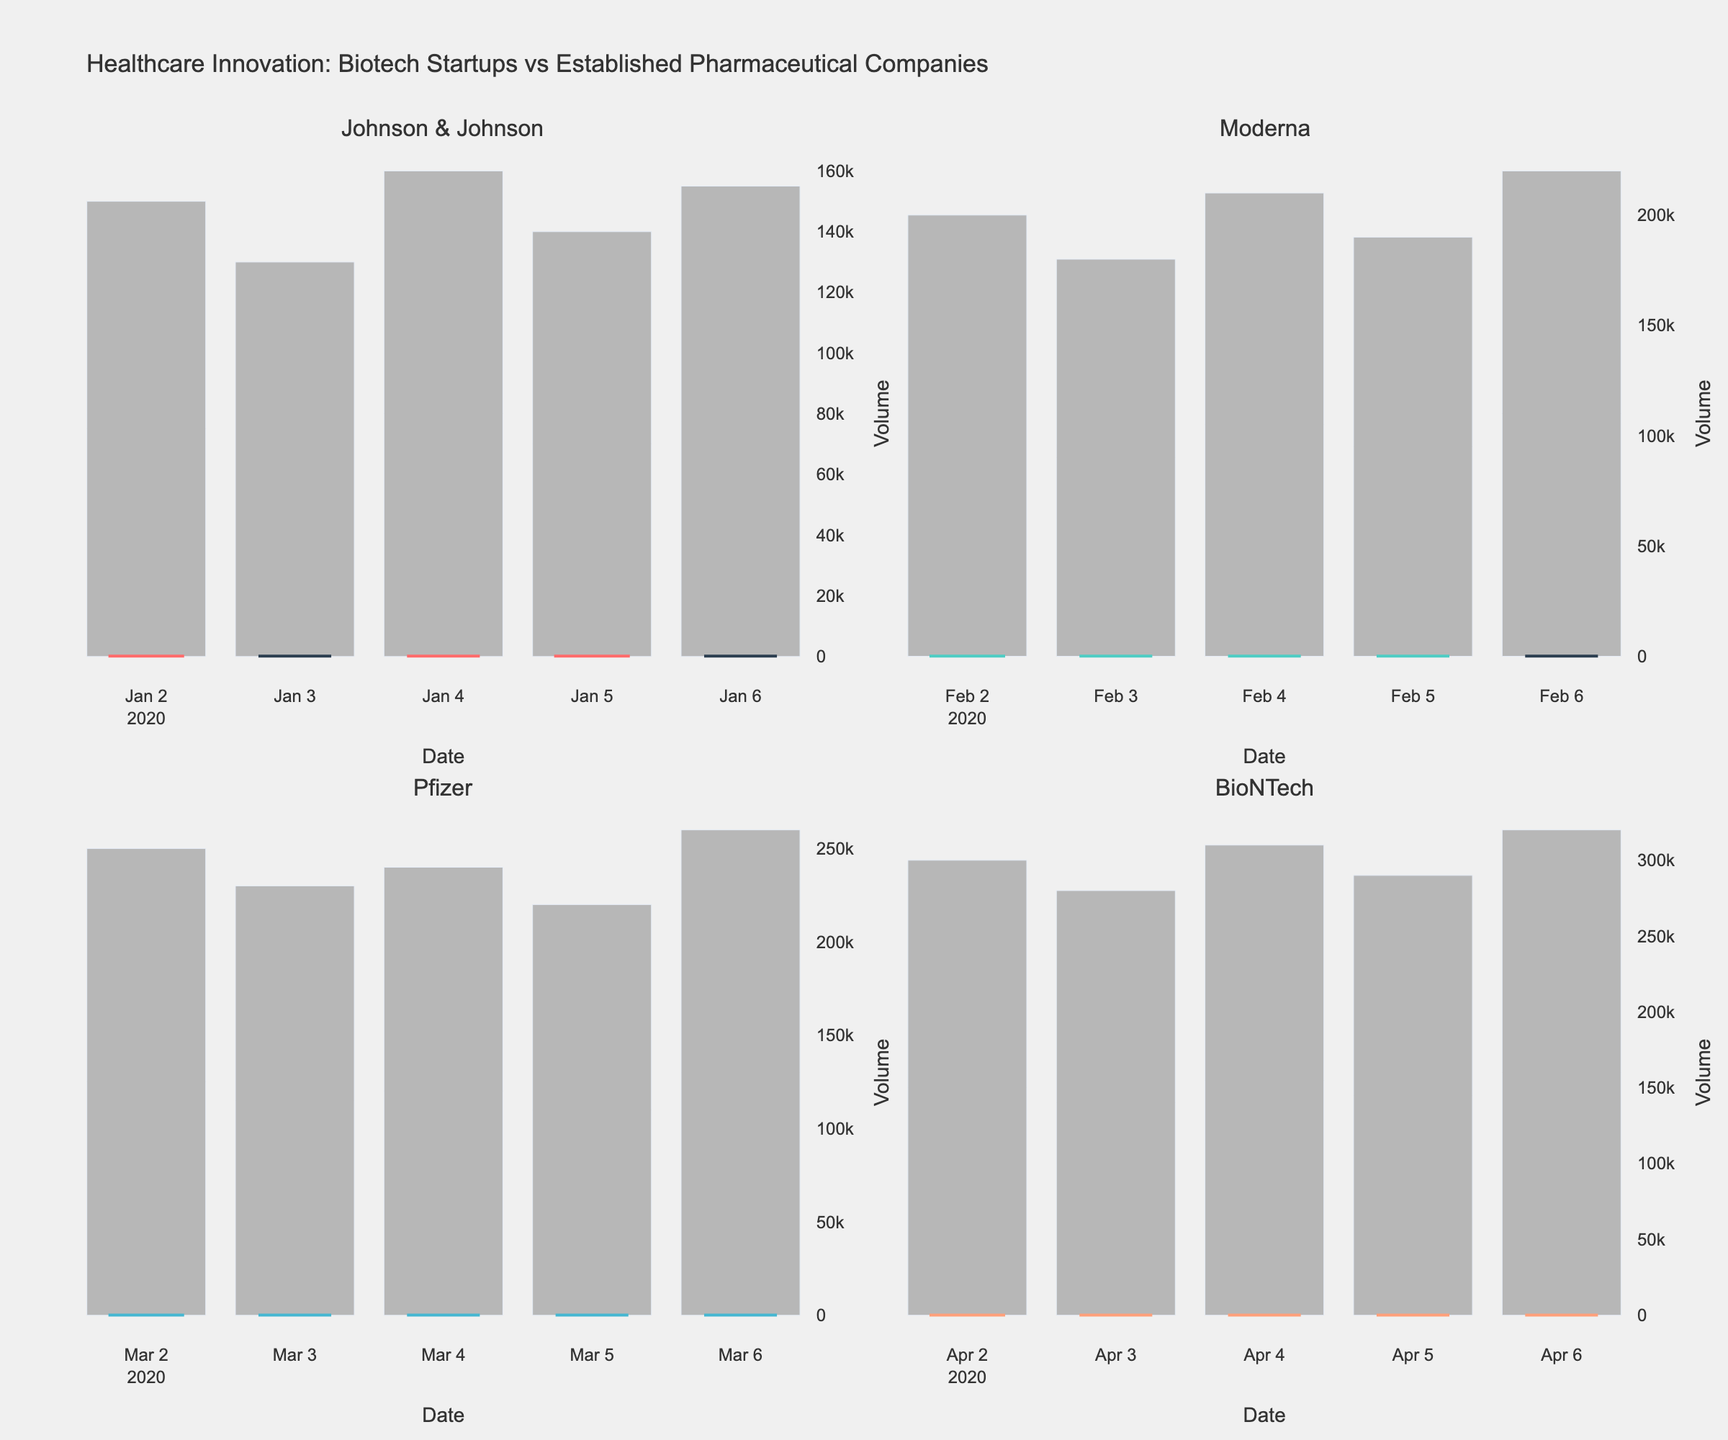How many companies are compared in the figure? There are four subplot titles, each representing a different company.
Answer: 4 What's the average closing price of BioNTech during the given period? The closing prices for BioNTech are 87.50, 89.00, 90.50, 92.00, and 94.00. Sum these values and divide by the number of data points. (87.50 + 89.00 + 90.50 + 92.00 + 94.00) / 5 = 453 / 5 = 90.60
Answer: 90.60 How does the volume of trades for Moderna on the highest volume day compare to that of BioNTech on its highest volume day? The highest volume for Moderna is 220,000, and for BioNTech it's 320,000. The volume for BioNTech on its highest volume day is greater than that of Moderna.
Answer: BioNTech has higher volume What is the overall trend of Pfizer's closing prices over the given period? By examining the candlestick pattern for Pfizer, the closing prices start at 103.50 and end at 109.00. The prices show an upward trend over the given period.
Answer: Upward trend Which company has the highest closing price among all the given companies? By scanning the closing prices in the candlestick charts, the highest closing price is 127.80 from Johnson & Johnson.
Answer: Johnson & Johnson What is the difference between the highest and lowest closing prices for Johnson & Johnson? The highest closing price for Johnson & Johnson is 127.80, and the lowest is 124.00. The difference is 127.80 - 124.00 = 3.80.
Answer: 3.80 Did any company have a decreasing closing price over all the days in the given period? By analyzing the closing prices in each candlestick chart, all companies have days where prices increased and days where they decreased. No company had a uniformly decreasing closing price.
Answer: No How does the highest closing price of a startup compare to the lowest closing price of an established company? The highest closing price of a startup is 94.00 by BioNTech. The lowest closing price of an established company is 103.50 by Pfizer. The highest closing price of a startup is lower than the lowest closing price of an established company.
Answer: Lower Which company experienced the greatest fluctuation in closing prices? The fluctuation can be determined by the difference between the highest and lowest closing prices for each company. Johnson & Johnson: 127.80 - 124.00 = 3.80, Moderna: 72.30 - 68.50 = 3.80, Pfizer: 109.00 - 103.50 = 5.50, BioNTech: 94.00 - 87.50 = 6.50. BioNTech shows the greatest fluctuation.
Answer: BioNTech 